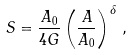<formula> <loc_0><loc_0><loc_500><loc_500>S = \frac { A _ { 0 } } { 4 G } \left ( \frac { A } { A _ { 0 } } \right ) ^ { \delta } \, ,</formula> 